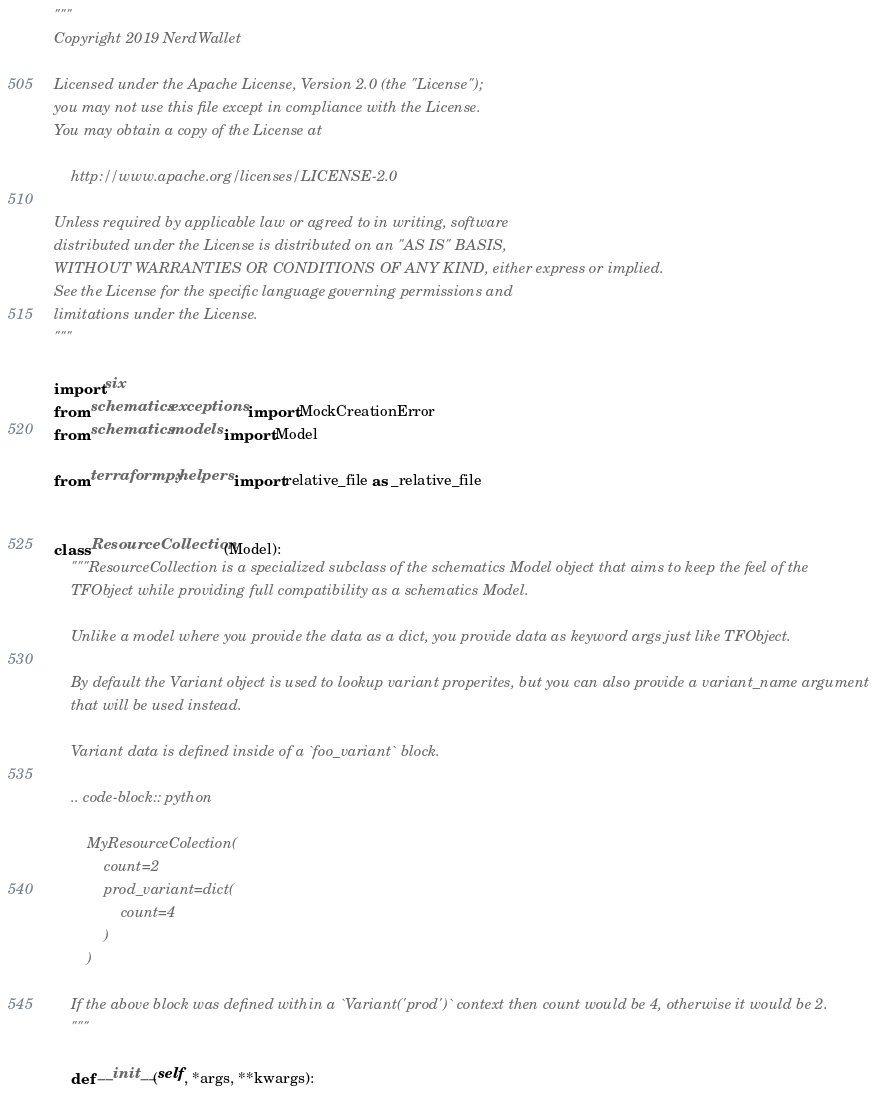Convert code to text. <code><loc_0><loc_0><loc_500><loc_500><_Python_>"""
Copyright 2019 NerdWallet

Licensed under the Apache License, Version 2.0 (the "License");
you may not use this file except in compliance with the License.
You may obtain a copy of the License at

    http://www.apache.org/licenses/LICENSE-2.0

Unless required by applicable law or agreed to in writing, software
distributed under the License is distributed on an "AS IS" BASIS,
WITHOUT WARRANTIES OR CONDITIONS OF ANY KIND, either express or implied.
See the License for the specific language governing permissions and
limitations under the License.
"""

import six
from schematics.exceptions import MockCreationError
from schematics.models import Model

from terraformpy.helpers import relative_file as _relative_file


class ResourceCollection(Model):
    """ResourceCollection is a specialized subclass of the schematics Model object that aims to keep the feel of the
    TFObject while providing full compatibility as a schematics Model.

    Unlike a model where you provide the data as a dict, you provide data as keyword args just like TFObject.

    By default the Variant object is used to lookup variant properites, but you can also provide a variant_name argument
    that will be used instead.

    Variant data is defined inside of a `foo_variant` block.

    .. code-block:: python

        MyResourceColection(
            count=2
            prod_variant=dict(
                count=4
            )
        )

    If the above block was defined within a `Variant('prod')` context then count would be 4, otherwise it would be 2.
    """

    def __init__(self, *args, **kwargs):</code> 